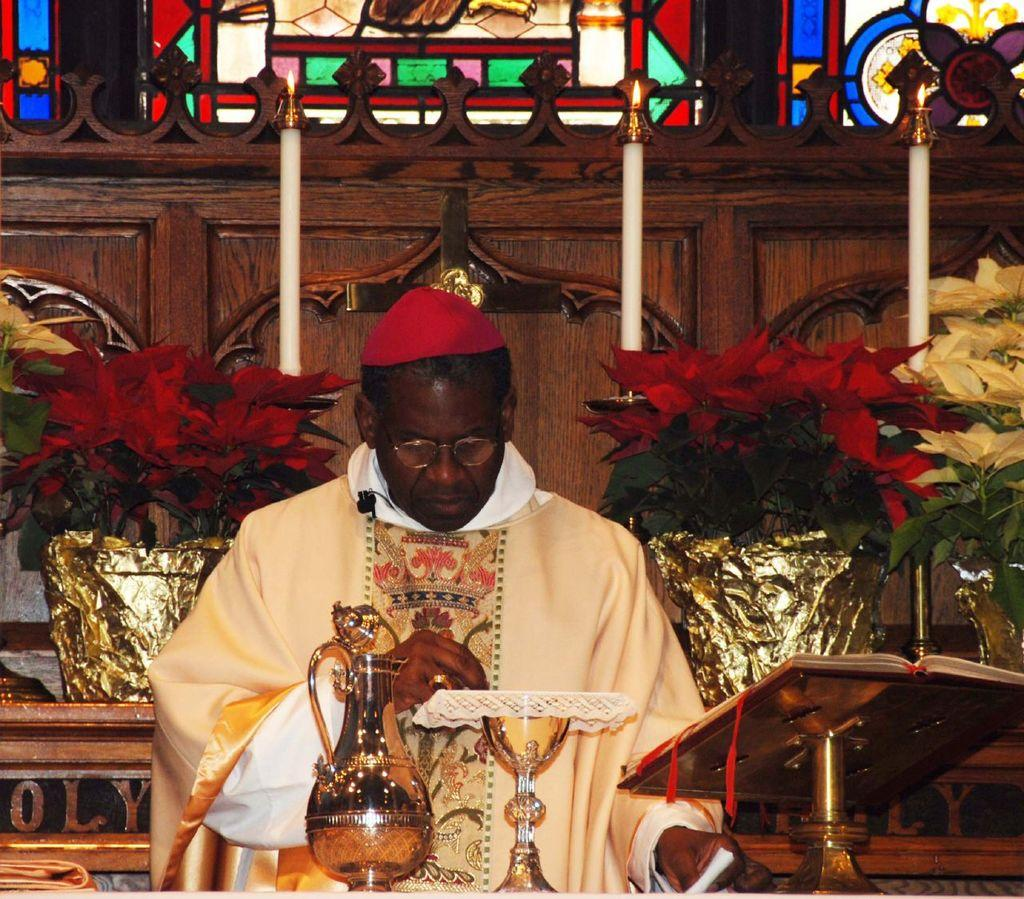What type of container is visible in the image? There is a glass and a jar in the image. Who is present in the image? A man is standing in the image. What type of vegetation is visible in the image? There are plants visible in the image. What type of lighting is present in the image? There are candles in the image. What type of structure is visible in the image? There is a wall in the image. How many ghosts are present in the image? There are no ghosts present in the image. What is the amount of water in the glass in the image? The amount of water in the glass cannot be determined from the image alone. 